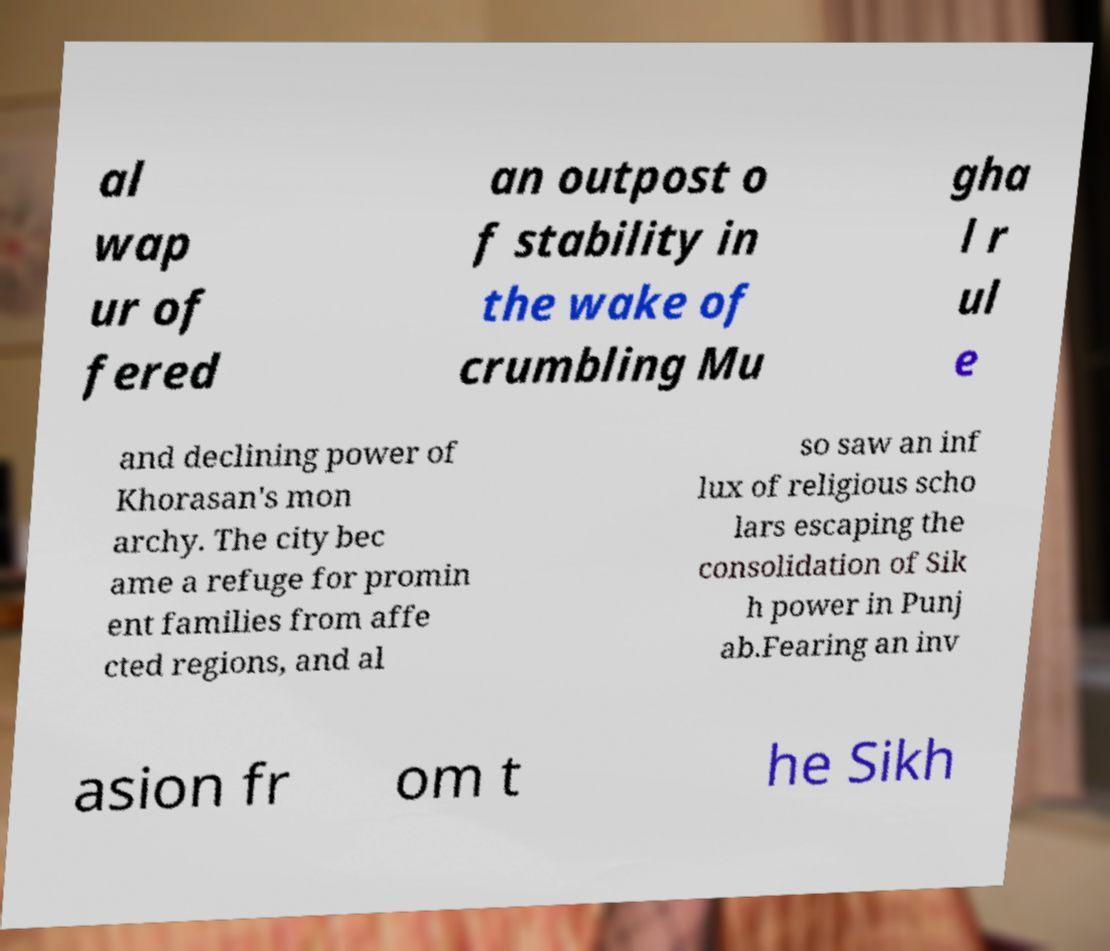Can you accurately transcribe the text from the provided image for me? al wap ur of fered an outpost o f stability in the wake of crumbling Mu gha l r ul e and declining power of Khorasan's mon archy. The city bec ame a refuge for promin ent families from affe cted regions, and al so saw an inf lux of religious scho lars escaping the consolidation of Sik h power in Punj ab.Fearing an inv asion fr om t he Sikh 